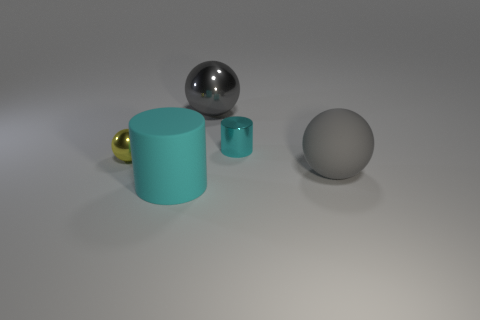Are there any metallic objects behind the tiny metallic thing right of the yellow metallic object? Yes, there is a gray metallic sphere located behind the small blue metallic cylinder, which is positioned to the right of the golden metallic sphere. 